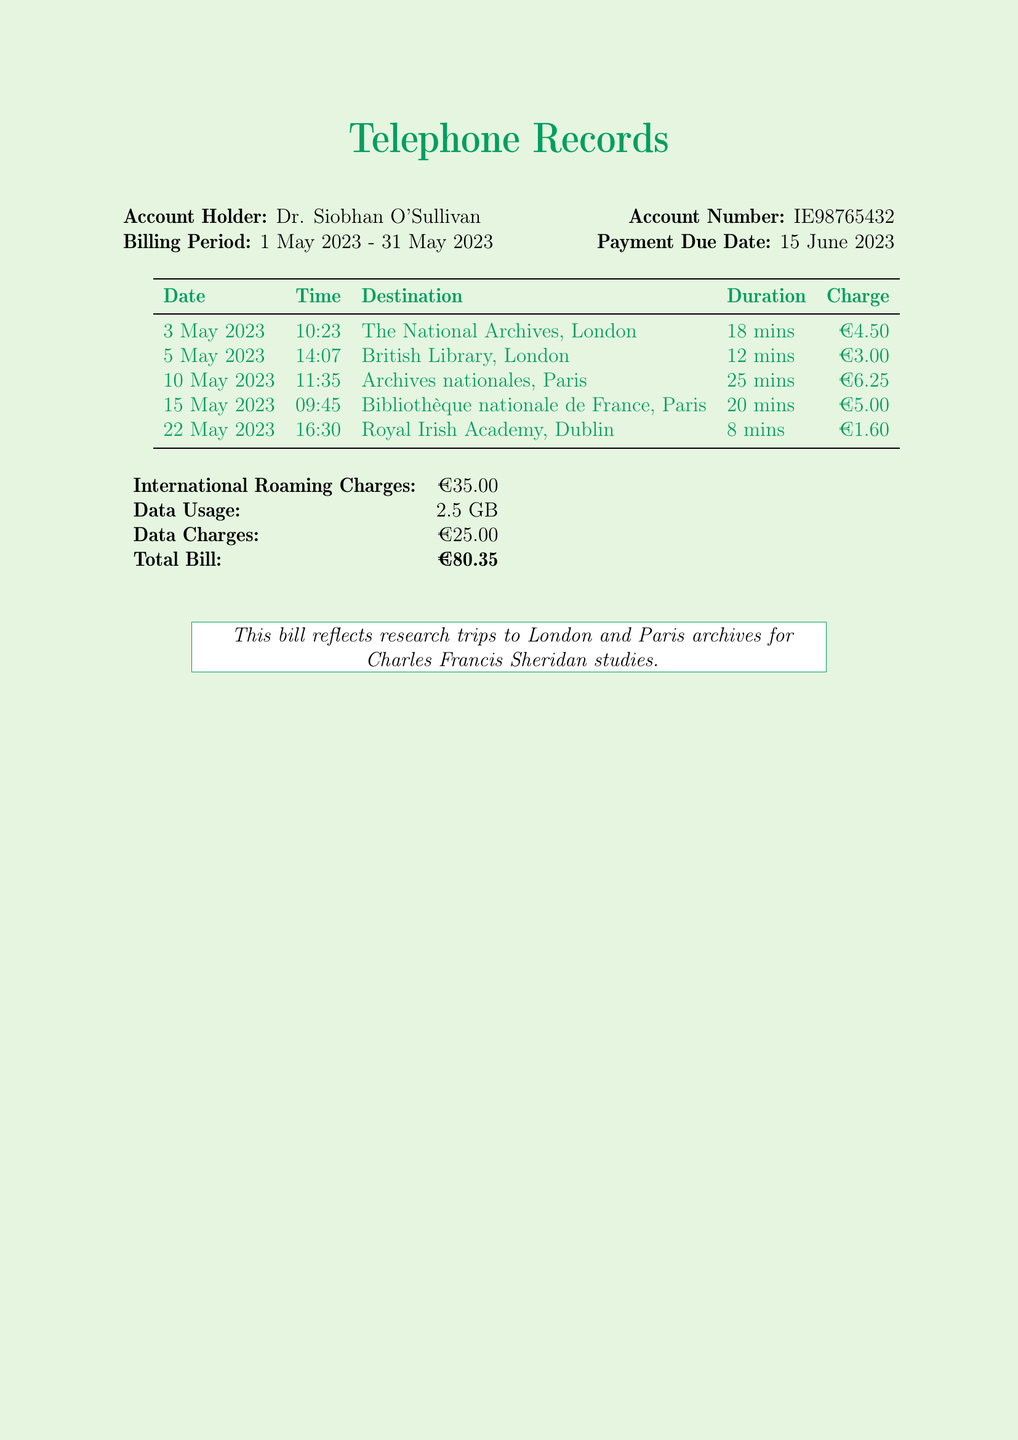What is the account holder's name? The account holder's name is mentioned at the top of the document.
Answer: Dr. Siobhan O'Sullivan What is the billing period? The billing period is specified in the document under the account holder's details.
Answer: 1 May 2023 - 31 May 2023 How much was charged for the call to the British Library? The charge for the British Library call is listed in the itemized table.
Answer: €3.00 What was the duration of the call to the Archives nationales? The duration for the Archives nationales call can be found in the table of calls.
Answer: 25 mins What is the total bill amount? The total bill is summarized at the end of the document.
Answer: €80.35 What is the total international roaming charge? The document includes a specific line for the international roaming charge.
Answer: €35.00 How many minutes did the call to The National Archives last? The call duration for The National Archives is mentioned in the call table.
Answer: 18 mins What archive was called on 15 May 2023? The specific archive can be found by checking the date in the call log.
Answer: Bibliothèque nationale de France How many GB of data were used? The data usage is clearly indicated in the summary section of the document.
Answer: 2.5 GB 